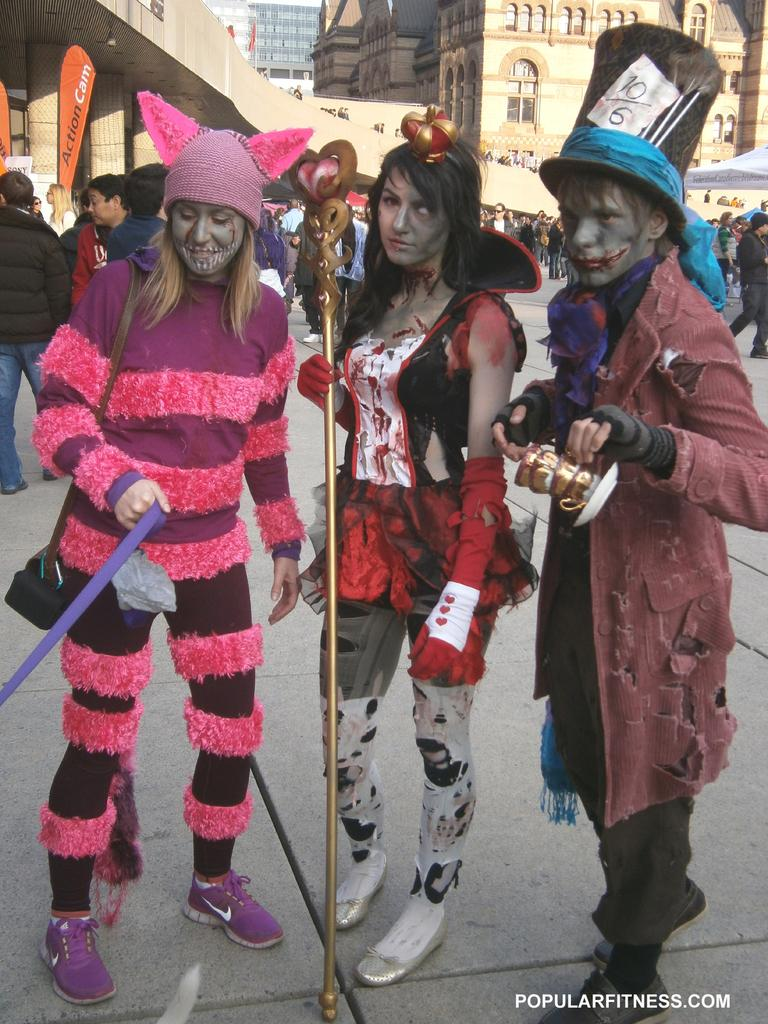What is happening in the center of the image? There are persons standing in the center of the image. What surface are the persons standing on? The persons are standing on the floor. What can be seen in the distance behind the persons? There are buildings and a road visible in the background of the image. Are there any other people in the image besides the ones in the center? Yes, there are persons in the background of the image. What type of soap is being used by the persons in the image? There is no soap present in the image; the persons are simply standing. What kind of spade can be seen being used by the persons in the image? There is no spade present in the image; the persons are not using any tools. 